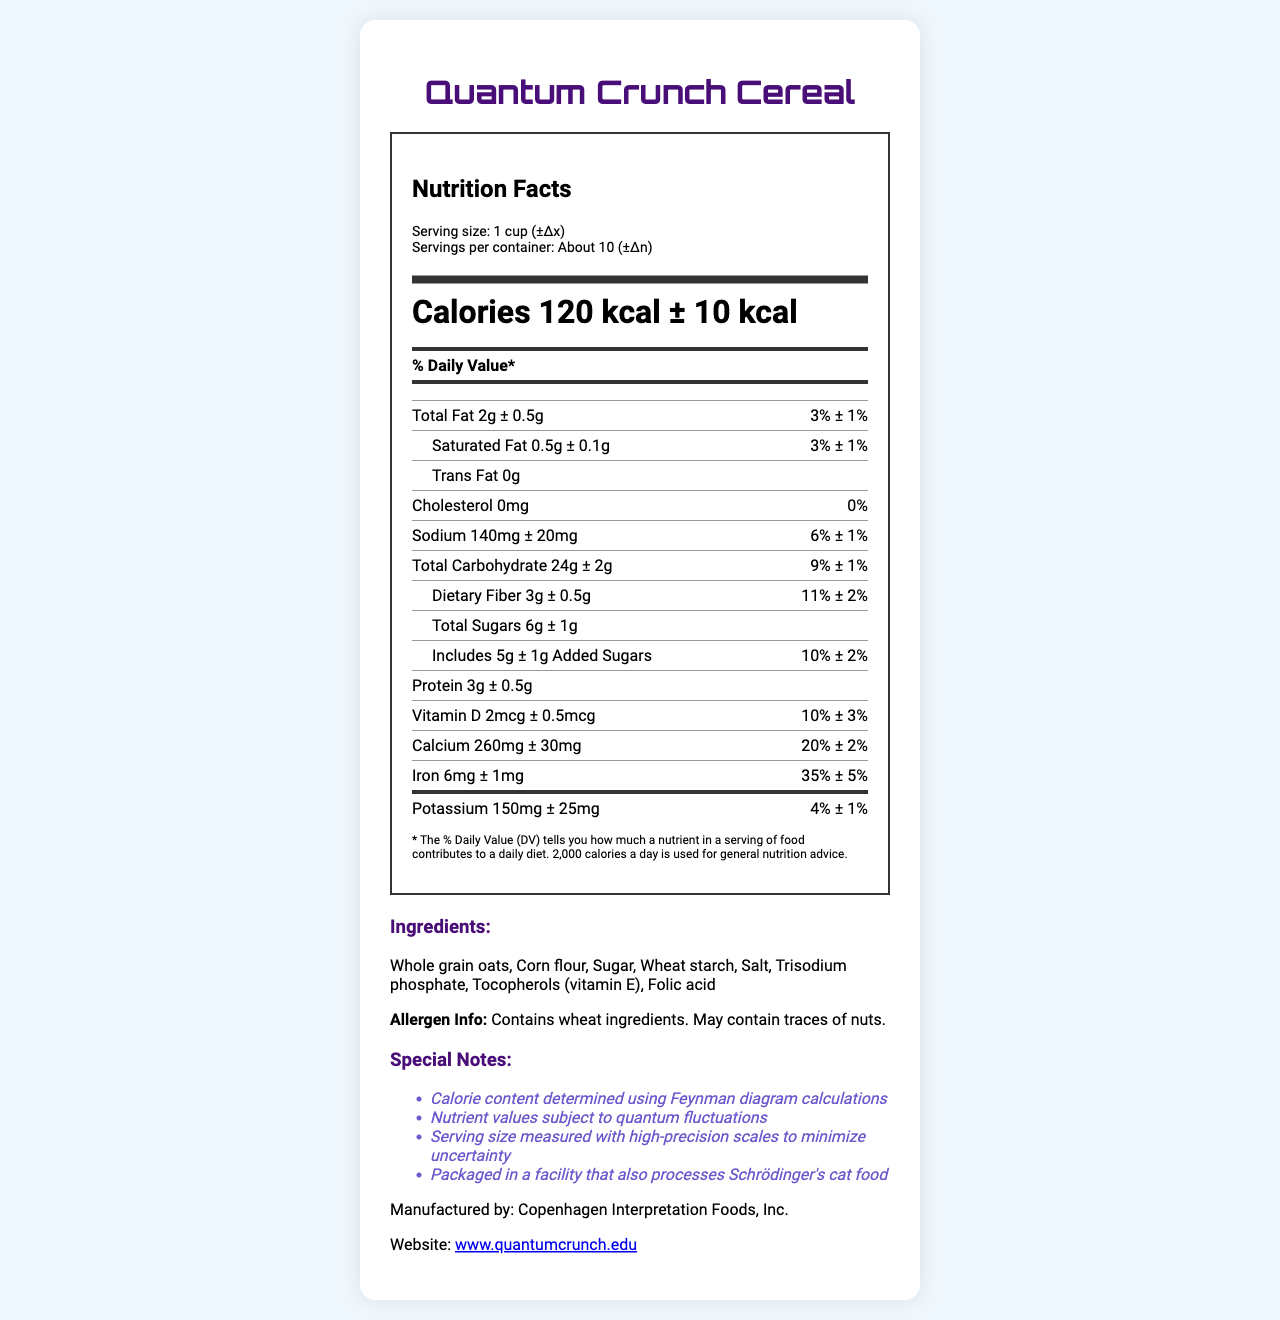what is the serving size for Quantum Crunch Cereal? The serving size is listed as "1 cup (±Δx)" in the document.
Answer: 1 cup (±Δx) how many calories are in one serving of Quantum Crunch Cereal? The calories per serving are specified as "120 kcal ± 10 kcal."
Answer: 120 kcal ± 10 kcal what are the main ingredients listed in Quantum Crunch Cereal? The ingredients are mentioned toward the end of the document under the "Ingredients" section.
Answer: Whole grain oats, Corn flour, Sugar, Wheat starch, Salt, Trisodium phosphate, Tocopherols (vitamin E), Folic acid how much protein is in one serving of Quantum Crunch Cereal? The protein content per serving is listed as "3g ± 0.5g."
Answer: 3g ± 0.5g what is the daily value percentage for calcium in one serving? The daily value for calcium is listed as "20% ± 2%."
Answer: 20% ± 2% which amount of sodium is closest to the listed uncertainty range? A. 150mg B. 140mg C. 130mg D. 120mg Sodium amount is specified as "140mg ± 20mg." 140mg fits this range exactly.
Answer: B how many servings are in one container of Quantum Crunch Cereal? A. 12 B. 8 C. About 10 D. 5 The servings per container are listed as "About 10 (±Δn)."
Answer: C which of the following nutrients has the highest daily value percentage? A. Vitamin D B. Calcium C. Iron D. Potassium Iron has the highest daily value of "35% ± 5%."
Answer: C does Quantum Crunch Cereal contain any trans fats? The document specifies "Trans Fat 0g."
Answer: No describe the uncertainty principle as it applies to Quantum Crunch Cereal's nutrition label. The label describes nutrient values with uncertainty ranges, indicating that the quantities could vary within this range, reflecting quantum fluctuations.
Answer: The nutrition label of Quantum Crunch Cereal incorporates uncertainty into traditional measurements. Each nutrient value is given with an associated uncertainty range (e.g., "120 kcal ± 10 kcal"). This suggests that the amounts of nutrients could fluctuate within the specified range, embodying the quantum concept of uncertainty. what year was the company Copenhagen Interpretation Foods, Inc. founded? The document does not provide the founding year of Copenhagen Interpretation Foods, Inc.
Answer: Not enough information 